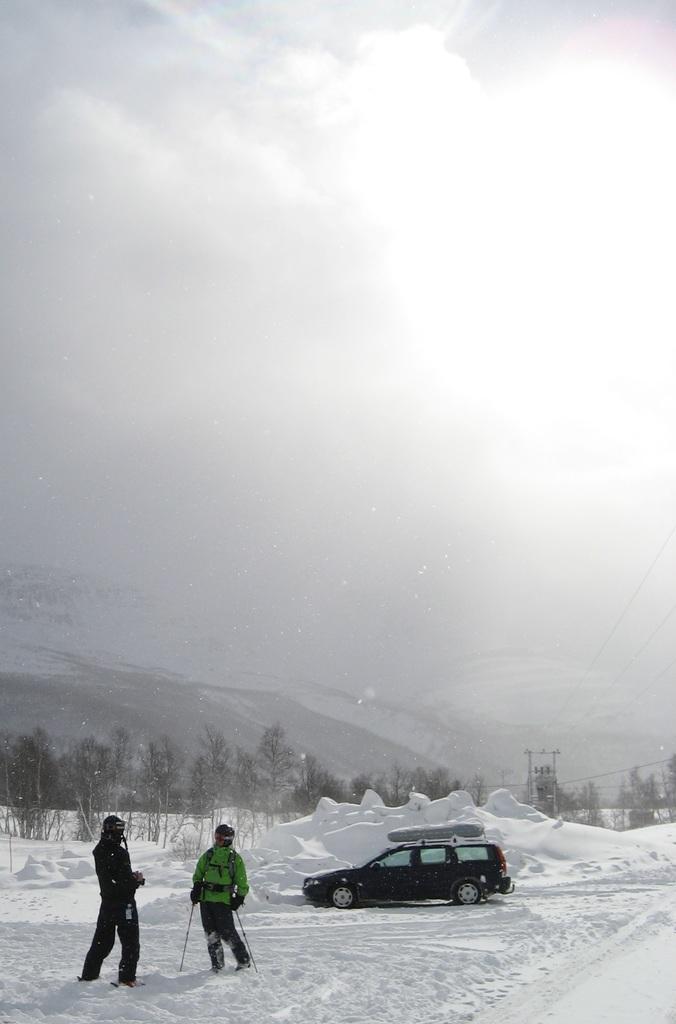Can you describe this image briefly? The man in the green jacket is holding skiing sticks in his hands. Beside him, the man in black jacket is standing. Behind them, we see a black car. At the bottom of the picture, we see ice and there are many trees and hills in the background and we even see transformer and wires. At the top of the picture, we see the sky. 